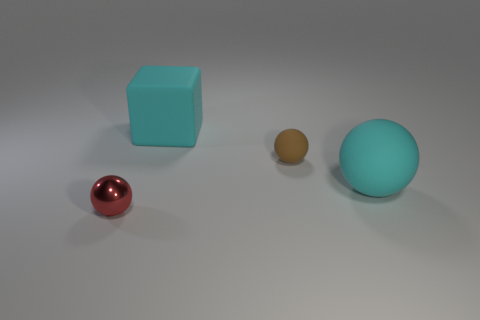Is there any other thing that is made of the same material as the red object?
Ensure brevity in your answer.  No. How many things are either small yellow matte things or small objects?
Ensure brevity in your answer.  2. How many other objects are made of the same material as the brown object?
Your response must be concise. 2. The cyan rubber thing that is the same shape as the red shiny object is what size?
Keep it short and to the point. Large. Are there any objects left of the cyan sphere?
Make the answer very short. Yes. What is the material of the tiny red ball?
Make the answer very short. Metal. There is a large matte object behind the tiny brown rubber ball; is its color the same as the large sphere?
Give a very brief answer. Yes. What is the color of the other large thing that is the same shape as the metallic thing?
Make the answer very short. Cyan. What is the material of the cyan object behind the brown sphere?
Offer a very short reply. Rubber. What is the color of the matte cube?
Your answer should be very brief. Cyan. 